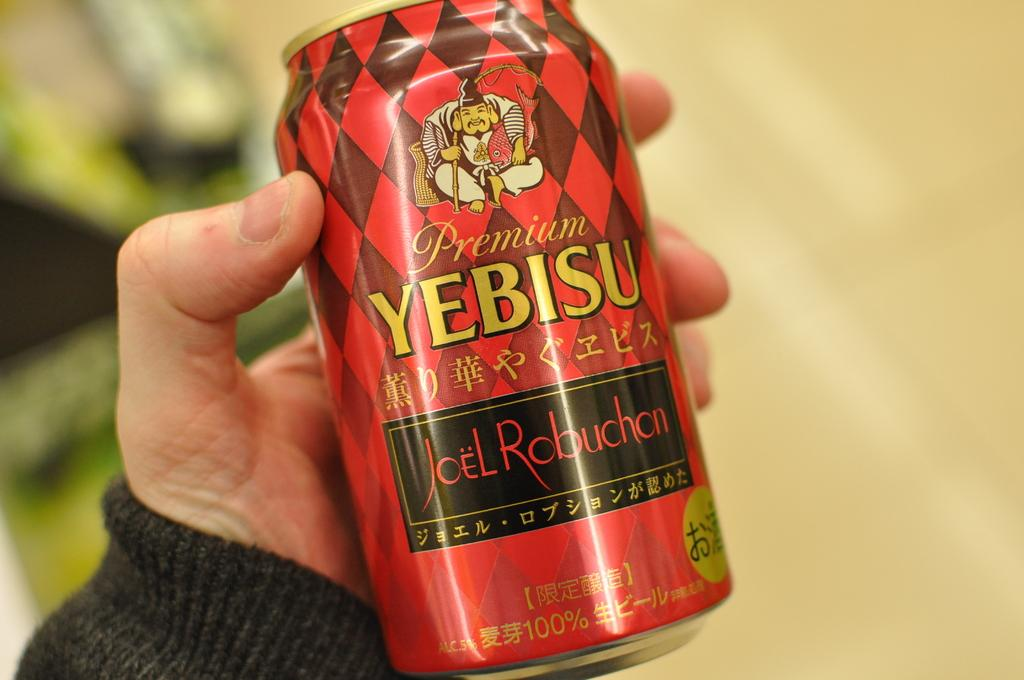<image>
Provide a brief description of the given image. Person holding red, gold and black can of YEBISU 